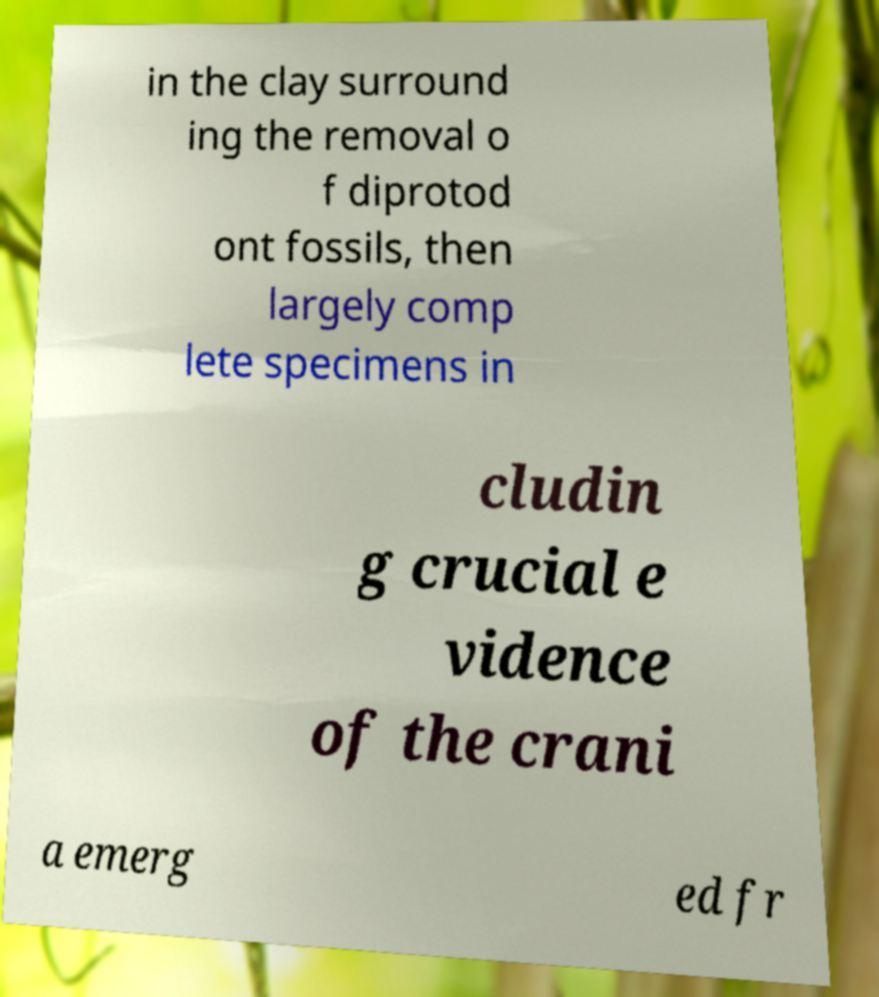Can you accurately transcribe the text from the provided image for me? in the clay surround ing the removal o f diprotod ont fossils, then largely comp lete specimens in cludin g crucial e vidence of the crani a emerg ed fr 